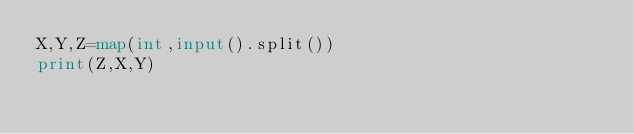<code> <loc_0><loc_0><loc_500><loc_500><_Python_>X,Y,Z=map(int,input().split())
print(Z,X,Y)</code> 